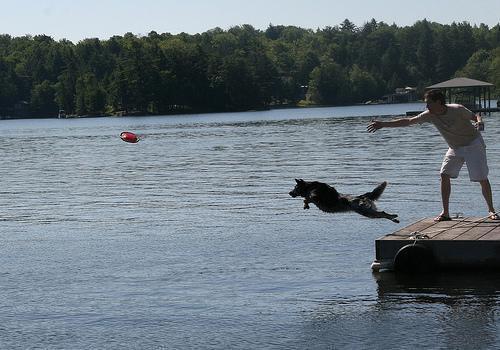How many dogs are there?
Give a very brief answer. 1. 